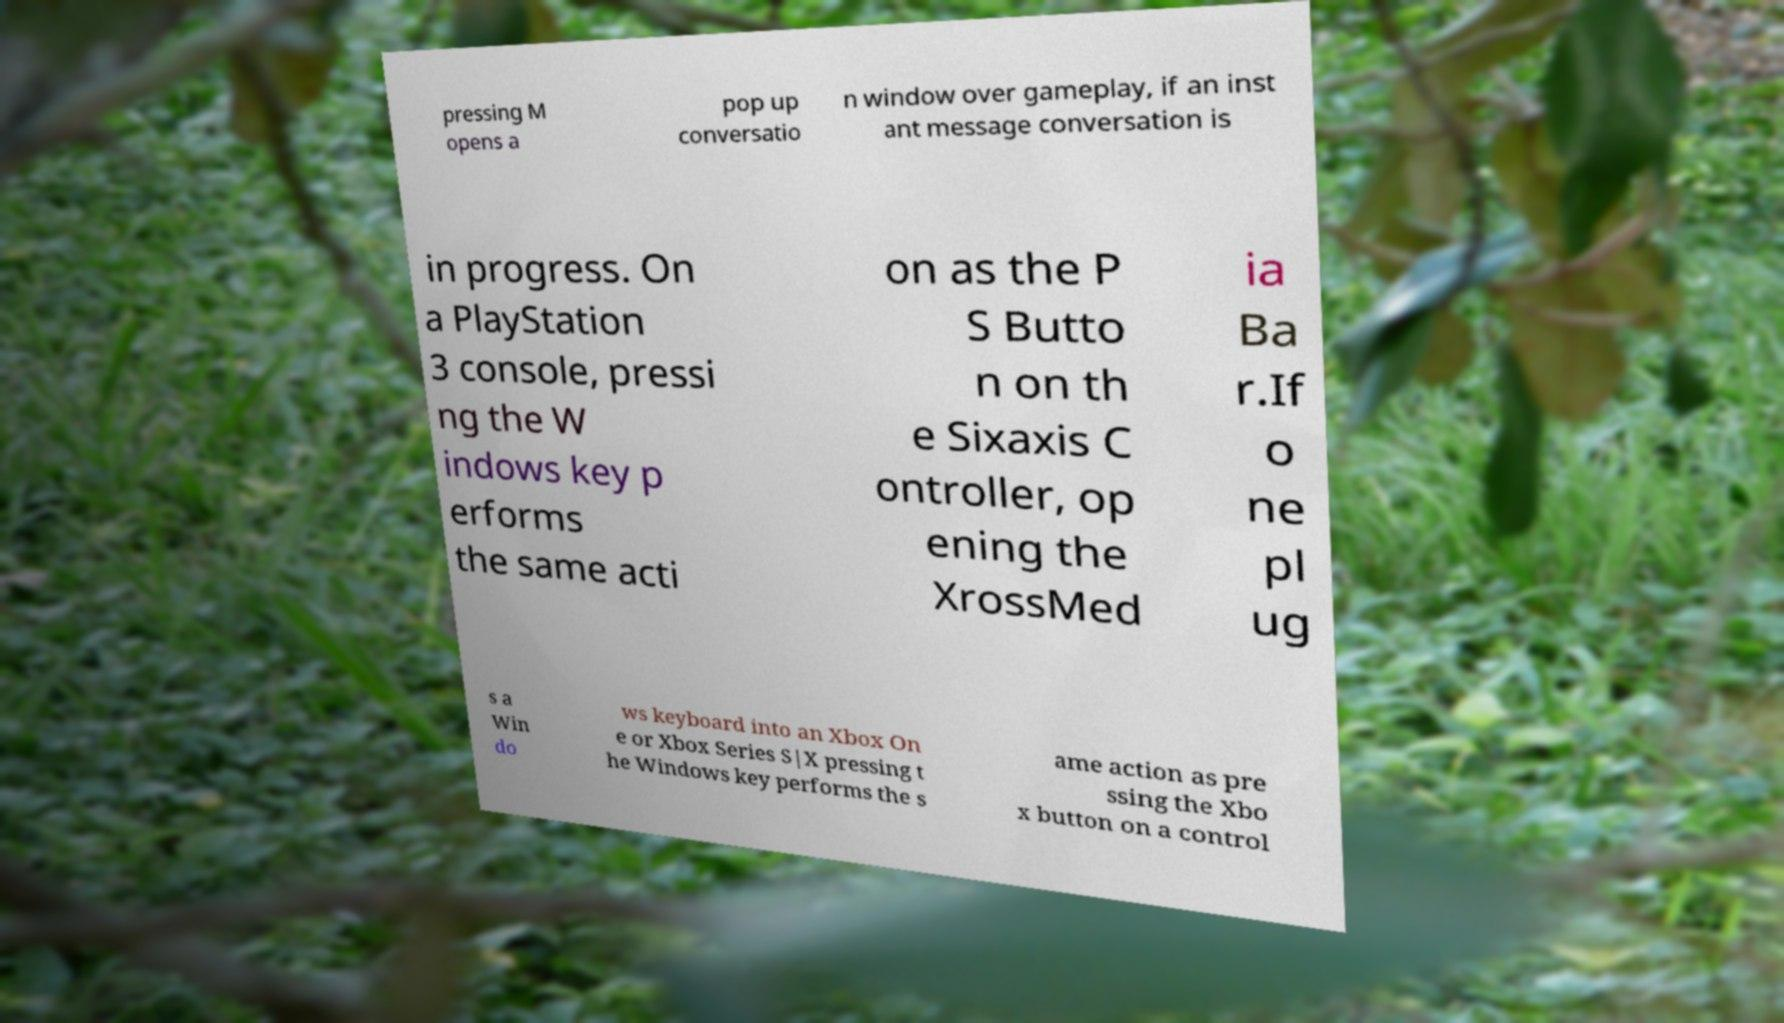Can you read and provide the text displayed in the image?This photo seems to have some interesting text. Can you extract and type it out for me? pressing M opens a pop up conversatio n window over gameplay, if an inst ant message conversation is in progress. On a PlayStation 3 console, pressi ng the W indows key p erforms the same acti on as the P S Butto n on th e Sixaxis C ontroller, op ening the XrossMed ia Ba r.If o ne pl ug s a Win do ws keyboard into an Xbox On e or Xbox Series S|X pressing t he Windows key performs the s ame action as pre ssing the Xbo x button on a control 